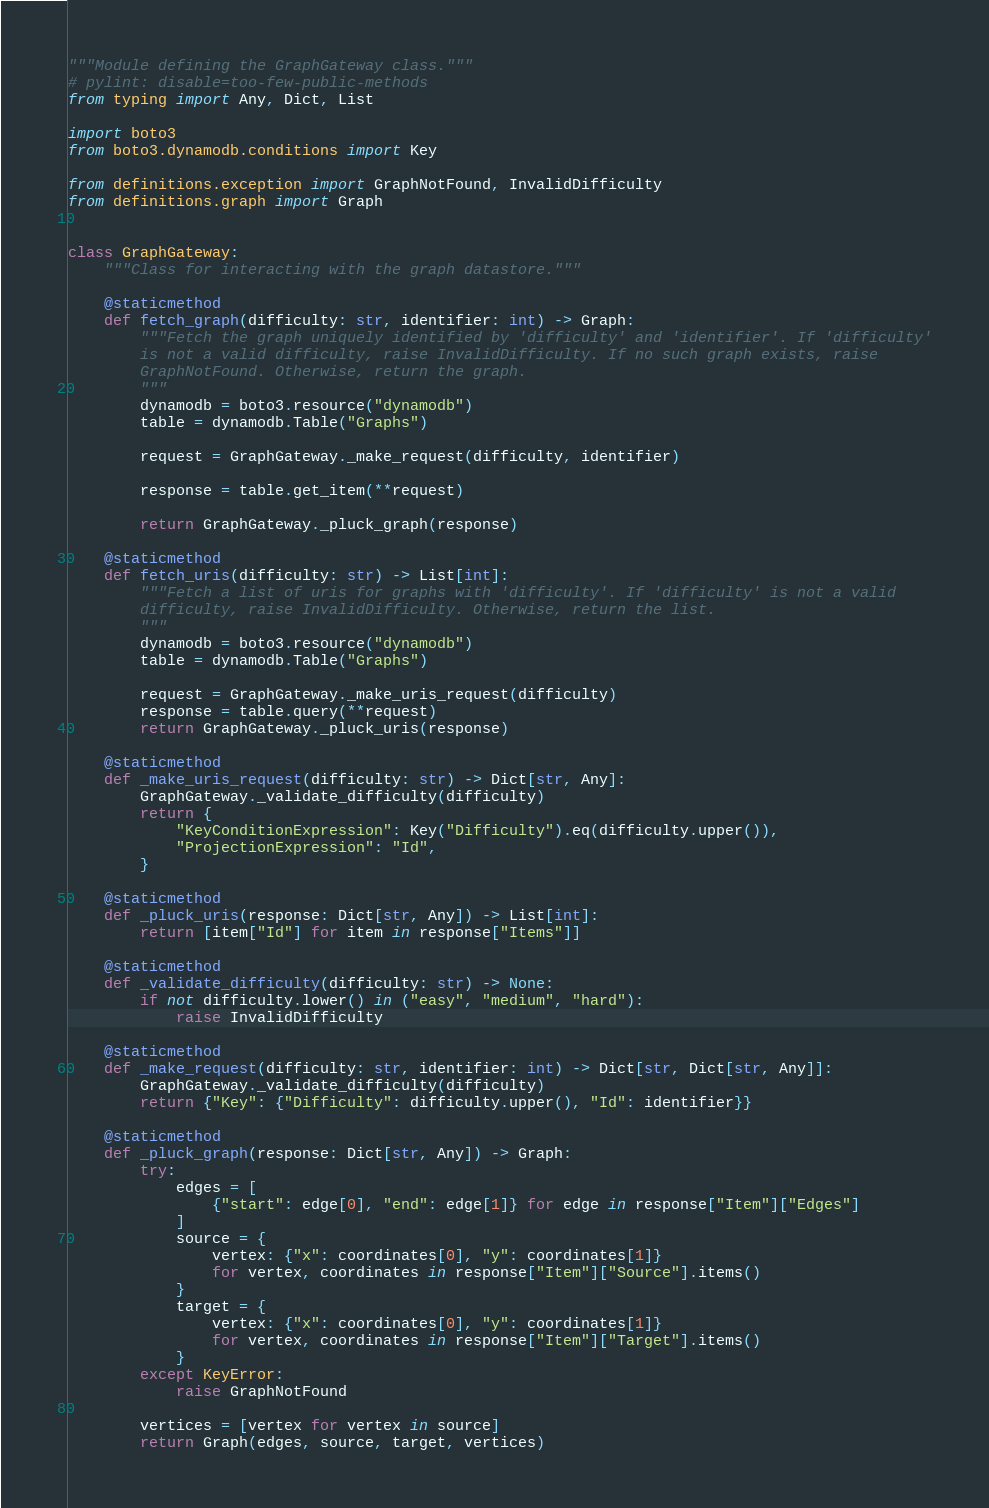Convert code to text. <code><loc_0><loc_0><loc_500><loc_500><_Python_>"""Module defining the GraphGateway class."""
# pylint: disable=too-few-public-methods
from typing import Any, Dict, List

import boto3
from boto3.dynamodb.conditions import Key

from definitions.exception import GraphNotFound, InvalidDifficulty
from definitions.graph import Graph


class GraphGateway:
    """Class for interacting with the graph datastore."""

    @staticmethod
    def fetch_graph(difficulty: str, identifier: int) -> Graph:
        """Fetch the graph uniquely identified by 'difficulty' and 'identifier'. If 'difficulty'
        is not a valid difficulty, raise InvalidDifficulty. If no such graph exists, raise
        GraphNotFound. Otherwise, return the graph.
        """
        dynamodb = boto3.resource("dynamodb")
        table = dynamodb.Table("Graphs")

        request = GraphGateway._make_request(difficulty, identifier)

        response = table.get_item(**request)

        return GraphGateway._pluck_graph(response)

    @staticmethod
    def fetch_uris(difficulty: str) -> List[int]:
        """Fetch a list of uris for graphs with 'difficulty'. If 'difficulty' is not a valid
        difficulty, raise InvalidDifficulty. Otherwise, return the list.
        """
        dynamodb = boto3.resource("dynamodb")
        table = dynamodb.Table("Graphs")

        request = GraphGateway._make_uris_request(difficulty)
        response = table.query(**request)
        return GraphGateway._pluck_uris(response)

    @staticmethod
    def _make_uris_request(difficulty: str) -> Dict[str, Any]:
        GraphGateway._validate_difficulty(difficulty)
        return {
            "KeyConditionExpression": Key("Difficulty").eq(difficulty.upper()),
            "ProjectionExpression": "Id",
        }

    @staticmethod
    def _pluck_uris(response: Dict[str, Any]) -> List[int]:
        return [item["Id"] for item in response["Items"]]

    @staticmethod
    def _validate_difficulty(difficulty: str) -> None:
        if not difficulty.lower() in ("easy", "medium", "hard"):
            raise InvalidDifficulty

    @staticmethod
    def _make_request(difficulty: str, identifier: int) -> Dict[str, Dict[str, Any]]:
        GraphGateway._validate_difficulty(difficulty)
        return {"Key": {"Difficulty": difficulty.upper(), "Id": identifier}}

    @staticmethod
    def _pluck_graph(response: Dict[str, Any]) -> Graph:
        try:
            edges = [
                {"start": edge[0], "end": edge[1]} for edge in response["Item"]["Edges"]
            ]
            source = {
                vertex: {"x": coordinates[0], "y": coordinates[1]}
                for vertex, coordinates in response["Item"]["Source"].items()
            }
            target = {
                vertex: {"x": coordinates[0], "y": coordinates[1]}
                for vertex, coordinates in response["Item"]["Target"].items()
            }
        except KeyError:
            raise GraphNotFound

        vertices = [vertex for vertex in source]
        return Graph(edges, source, target, vertices)
</code> 